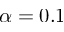Convert formula to latex. <formula><loc_0><loc_0><loc_500><loc_500>\alpha = 0 . 1</formula> 